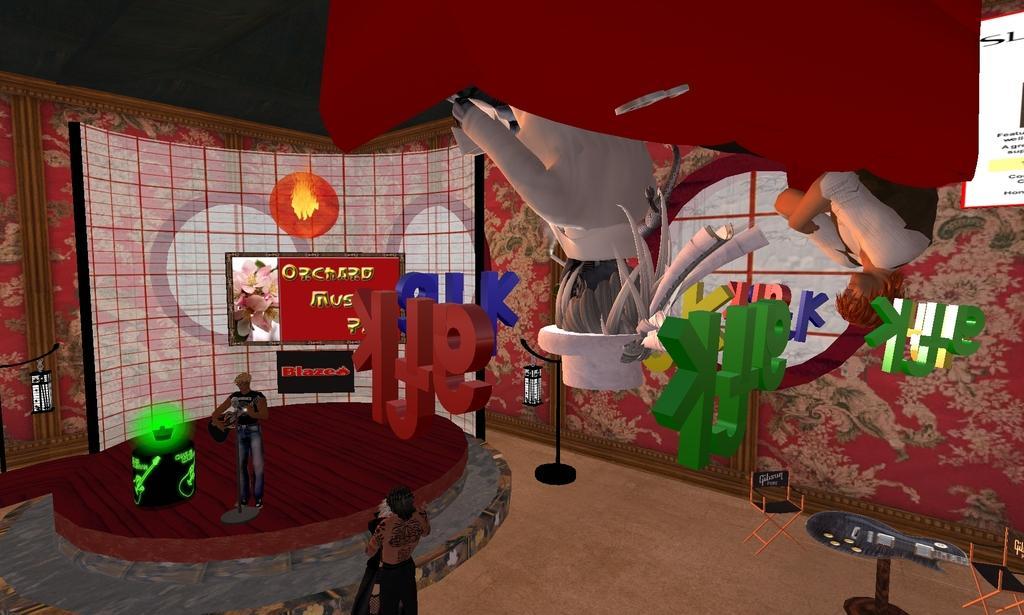Describe this image in one or two sentences. This is an animated image where we can see a few objects, few people and the wall which is in red color in the background. 